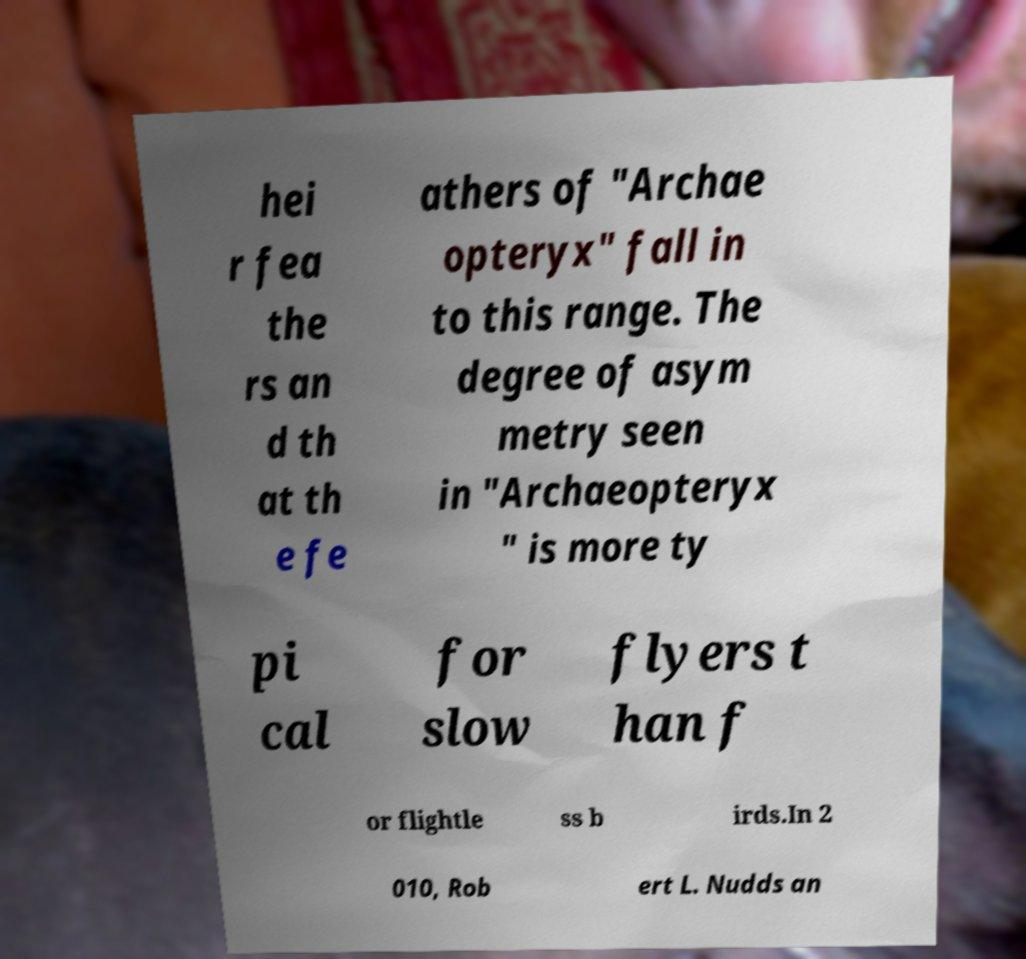Could you extract and type out the text from this image? hei r fea the rs an d th at th e fe athers of "Archae opteryx" fall in to this range. The degree of asym metry seen in "Archaeopteryx " is more ty pi cal for slow flyers t han f or flightle ss b irds.In 2 010, Rob ert L. Nudds an 